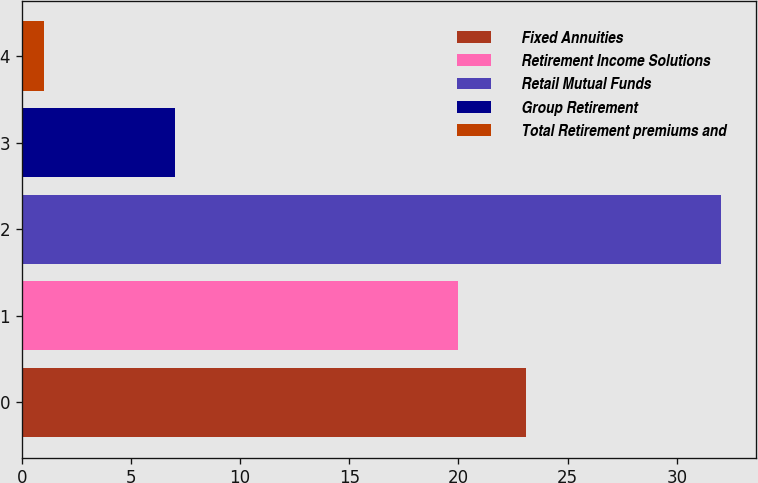Convert chart. <chart><loc_0><loc_0><loc_500><loc_500><bar_chart><fcel>Fixed Annuities<fcel>Retirement Income Solutions<fcel>Retail Mutual Funds<fcel>Group Retirement<fcel>Total Retirement premiums and<nl><fcel>23.1<fcel>20<fcel>32<fcel>7<fcel>1<nl></chart> 